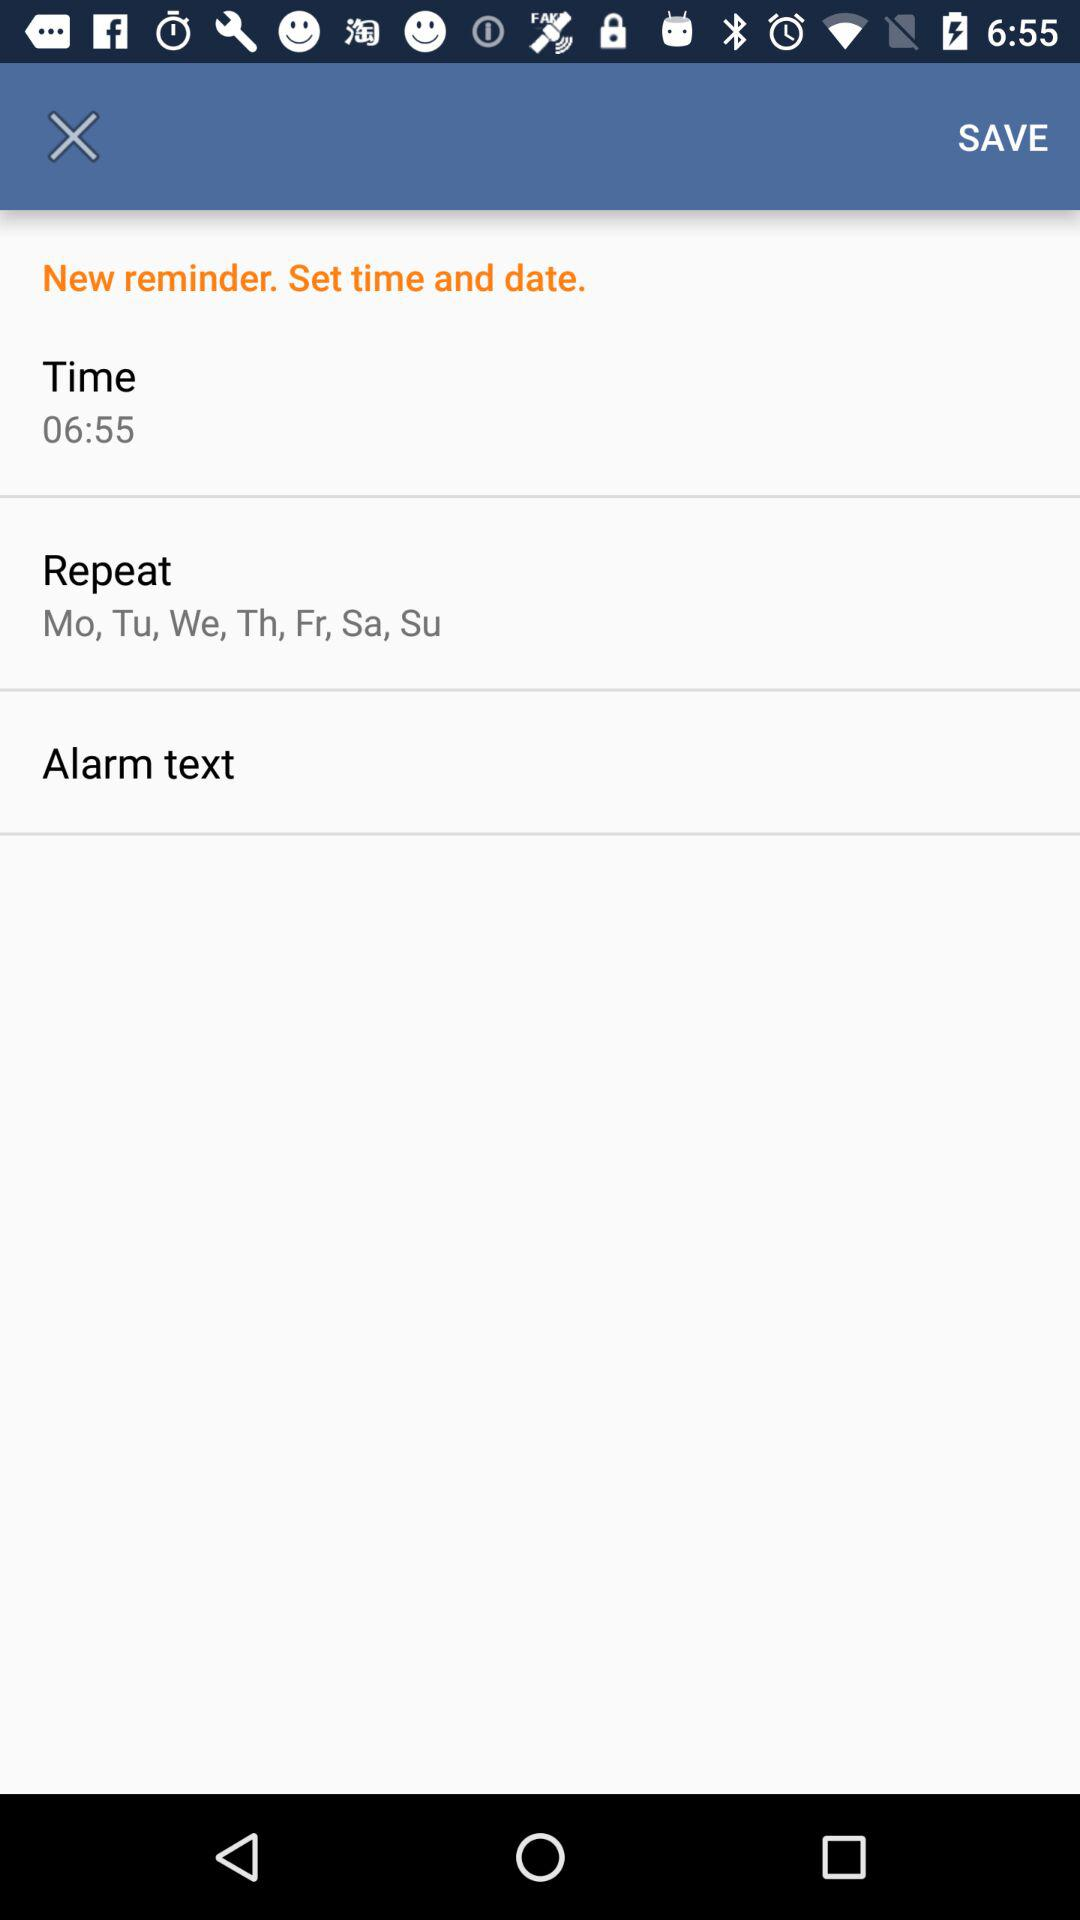What is the time? The time is 6:55. 